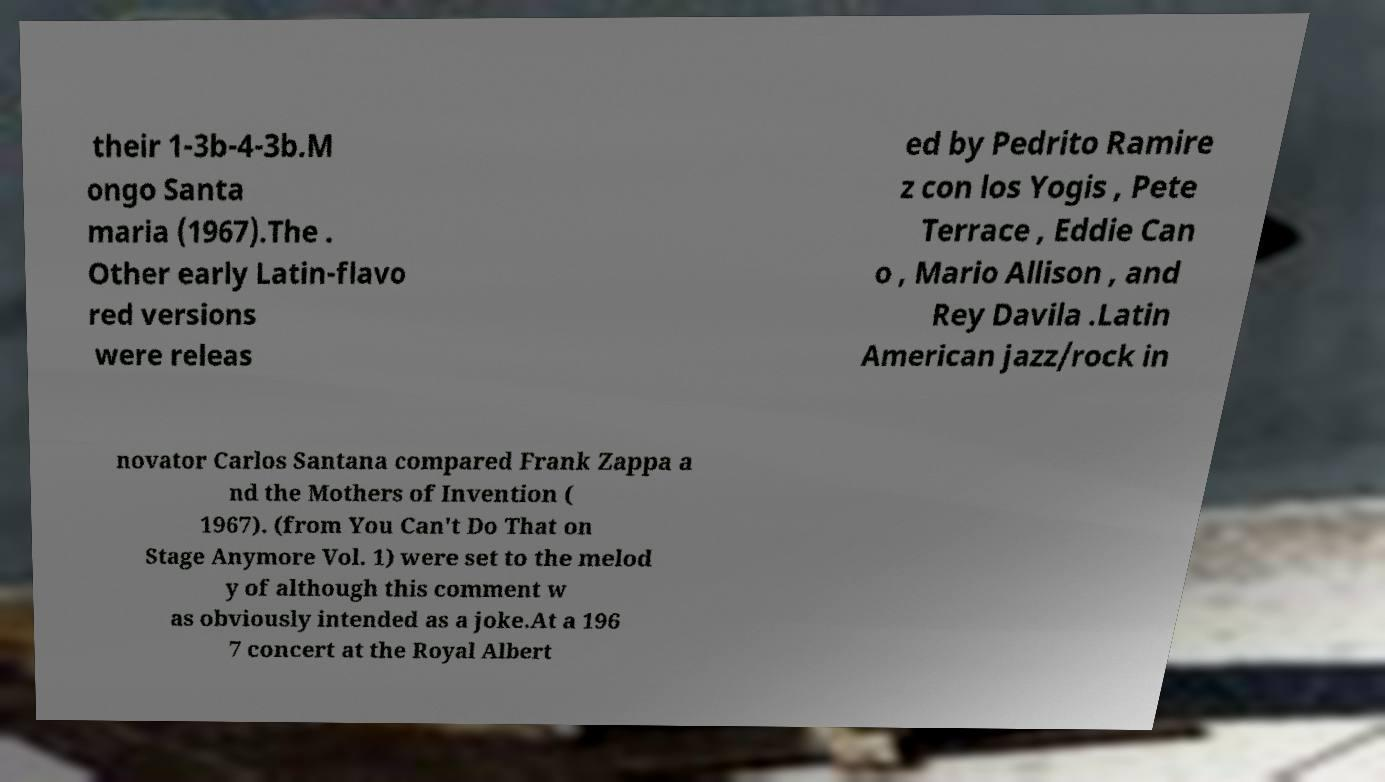I need the written content from this picture converted into text. Can you do that? their 1-3b-4-3b.M ongo Santa maria (1967).The . Other early Latin-flavo red versions were releas ed by Pedrito Ramire z con los Yogis , Pete Terrace , Eddie Can o , Mario Allison , and Rey Davila .Latin American jazz/rock in novator Carlos Santana compared Frank Zappa a nd the Mothers of Invention ( 1967). (from You Can't Do That on Stage Anymore Vol. 1) were set to the melod y of although this comment w as obviously intended as a joke.At a 196 7 concert at the Royal Albert 